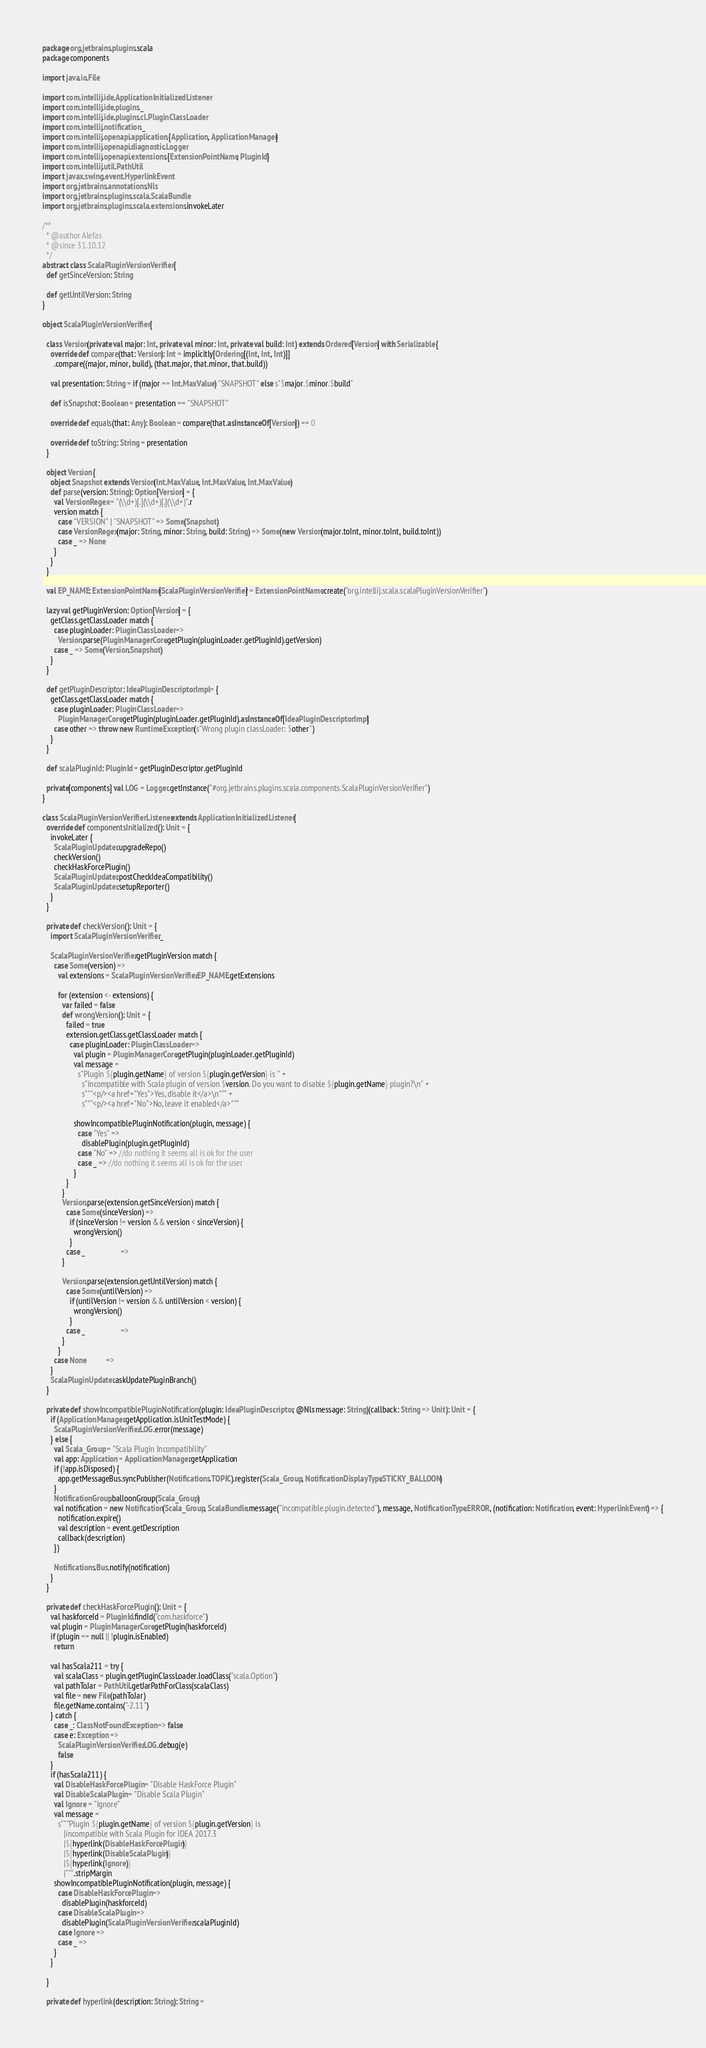<code> <loc_0><loc_0><loc_500><loc_500><_Scala_>package org.jetbrains.plugins.scala
package components

import java.io.File

import com.intellij.ide.ApplicationInitializedListener
import com.intellij.ide.plugins._
import com.intellij.ide.plugins.cl.PluginClassLoader
import com.intellij.notification._
import com.intellij.openapi.application.{Application, ApplicationManager}
import com.intellij.openapi.diagnostic.Logger
import com.intellij.openapi.extensions.{ExtensionPointName, PluginId}
import com.intellij.util.PathUtil
import javax.swing.event.HyperlinkEvent
import org.jetbrains.annotations.Nls
import org.jetbrains.plugins.scala.ScalaBundle
import org.jetbrains.plugins.scala.extensions.invokeLater

/**
  * @author Alefas
  * @since 31.10.12
  */
abstract class ScalaPluginVersionVerifier {
  def getSinceVersion: String

  def getUntilVersion: String
}

object ScalaPluginVersionVerifier {

  class Version(private val major: Int, private val minor: Int, private val build: Int) extends Ordered[Version] with Serializable {
    override def compare(that: Version): Int = implicitly[Ordering[(Int, Int, Int)]]
      .compare((major, minor, build), (that.major, that.minor, that.build))

    val presentation: String = if (major == Int.MaxValue) "SNAPSHOT" else s"$major.$minor.$build"

    def isSnapshot: Boolean = presentation == "SNAPSHOT"

    override def equals(that: Any): Boolean = compare(that.asInstanceOf[Version]) == 0

    override def toString: String = presentation
  }

  object Version {
    object Snapshot extends Version(Int.MaxValue, Int.MaxValue, Int.MaxValue)
    def parse(version: String): Option[Version] = {
      val VersionRegex = "(\\d+)[.](\\d+)[.](\\d+)".r
      version match {
        case "VERSION" | "SNAPSHOT" => Some(Snapshot)
        case VersionRegex(major: String, minor: String, build: String) => Some(new Version(major.toInt, minor.toInt, build.toInt))
        case _ => None
      }
    }
  }

  val EP_NAME: ExtensionPointName[ScalaPluginVersionVerifier] = ExtensionPointName.create("org.intellij.scala.scalaPluginVersionVerifier")

  lazy val getPluginVersion: Option[Version] = {
    getClass.getClassLoader match {
      case pluginLoader: PluginClassLoader =>
        Version.parse(PluginManagerCore.getPlugin(pluginLoader.getPluginId).getVersion)
      case _ => Some(Version.Snapshot)
    }
  }

  def getPluginDescriptor: IdeaPluginDescriptorImpl = {
    getClass.getClassLoader match {
      case pluginLoader: PluginClassLoader =>
        PluginManagerCore.getPlugin(pluginLoader.getPluginId).asInstanceOf[IdeaPluginDescriptorImpl]
      case other => throw new RuntimeException(s"Wrong plugin classLoader: $other")
    }
  }

  def scalaPluginId: PluginId = getPluginDescriptor.getPluginId

  private[components] val LOG = Logger.getInstance("#org.jetbrains.plugins.scala.components.ScalaPluginVersionVerifier")
}

class ScalaPluginVersionVerifierListener extends ApplicationInitializedListener {
  override def componentsInitialized(): Unit = {
    invokeLater {
      ScalaPluginUpdater.upgradeRepo()
      checkVersion()
      checkHaskForcePlugin()
      ScalaPluginUpdater.postCheckIdeaCompatibility()
      ScalaPluginUpdater.setupReporter()
    }
  }

  private def checkVersion(): Unit = {
    import ScalaPluginVersionVerifier._

    ScalaPluginVersionVerifier.getPluginVersion match {
      case Some(version) =>
        val extensions = ScalaPluginVersionVerifier.EP_NAME.getExtensions

        for (extension <- extensions) {
          var failed = false
          def wrongVersion(): Unit = {
            failed = true
            extension.getClass.getClassLoader match {
              case pluginLoader: PluginClassLoader =>
                val plugin = PluginManagerCore.getPlugin(pluginLoader.getPluginId)
                val message =
                  s"Plugin ${plugin.getName} of version ${plugin.getVersion} is " +
                    s"incompatible with Scala plugin of version $version. Do you want to disable ${plugin.getName} plugin?\n" +
                    s"""<p/><a href="Yes">Yes, disable it</a>\n""" +
                    s"""<p/><a href="No">No, leave it enabled</a>"""

                showIncompatiblePluginNotification(plugin, message) {
                  case "Yes" =>
                    disablePlugin(plugin.getPluginId)
                  case "No" => //do nothing it seems all is ok for the user
                  case _ => //do nothing it seems all is ok for the user
                }
            }
          }
          Version.parse(extension.getSinceVersion) match {
            case Some(sinceVersion) =>
              if (sinceVersion != version && version < sinceVersion) {
                wrongVersion()
              }
            case _                  =>
          }

          Version.parse(extension.getUntilVersion) match {
            case Some(untilVersion) =>
              if (untilVersion != version && untilVersion < version) {
                wrongVersion()
              }
            case _                  =>
          }
        }
      case None          =>
    }
    ScalaPluginUpdater.askUpdatePluginBranch()
  }

  private def showIncompatiblePluginNotification(plugin: IdeaPluginDescriptor, @Nls message: String)(callback: String => Unit): Unit = {
    if (ApplicationManager.getApplication.isUnitTestMode) {
      ScalaPluginVersionVerifier.LOG.error(message)
    } else {
      val Scala_Group = "Scala Plugin Incompatibility"
      val app: Application = ApplicationManager.getApplication
      if (!app.isDisposed) {
        app.getMessageBus.syncPublisher(Notifications.TOPIC).register(Scala_Group, NotificationDisplayType.STICKY_BALLOON)
      }
      NotificationGroup.balloonGroup(Scala_Group)
      val notification = new Notification(Scala_Group, ScalaBundle.message("incompatible.plugin.detected"), message, NotificationType.ERROR, (notification: Notification, event: HyperlinkEvent) => {
        notification.expire()
        val description = event.getDescription
        callback(description)
      })

      Notifications.Bus.notify(notification)
    }
  }

  private def checkHaskForcePlugin(): Unit = {
    val haskforceId = PluginId.findId("com.haskforce")
    val plugin = PluginManagerCore.getPlugin(haskforceId)
    if (plugin == null || !plugin.isEnabled)
      return

    val hasScala211 = try {
      val scalaClass = plugin.getPluginClassLoader.loadClass("scala.Option")
      val pathToJar = PathUtil.getJarPathForClass(scalaClass)
      val file = new File(pathToJar)
      file.getName.contains("-2.11")
    } catch {
      case _: ClassNotFoundException => false
      case e: Exception =>
        ScalaPluginVersionVerifier.LOG.debug(e)
        false
    }
    if (hasScala211) {
      val DisableHaskForcePlugin = "Disable HaskForce Plugin"
      val DisableScalaPlugin = "Disable Scala Plugin"
      val Ignore = "Ignore"
      val message =
        s"""Plugin ${plugin.getName} of version ${plugin.getVersion} is
           |incompatible with Scala Plugin for IDEA 2017.3
           |${hyperlink(DisableHaskForcePlugin)}
           |${hyperlink(DisableScalaPlugin)}
           |${hyperlink(Ignore)}
           |""".stripMargin
      showIncompatiblePluginNotification(plugin, message) {
        case DisableHaskForcePlugin =>
          disablePlugin(haskforceId)
        case DisableScalaPlugin =>
          disablePlugin(ScalaPluginVersionVerifier.scalaPluginId)
        case Ignore =>
        case _ =>
      }
    }

  }

  private def hyperlink(description: String): String =</code> 